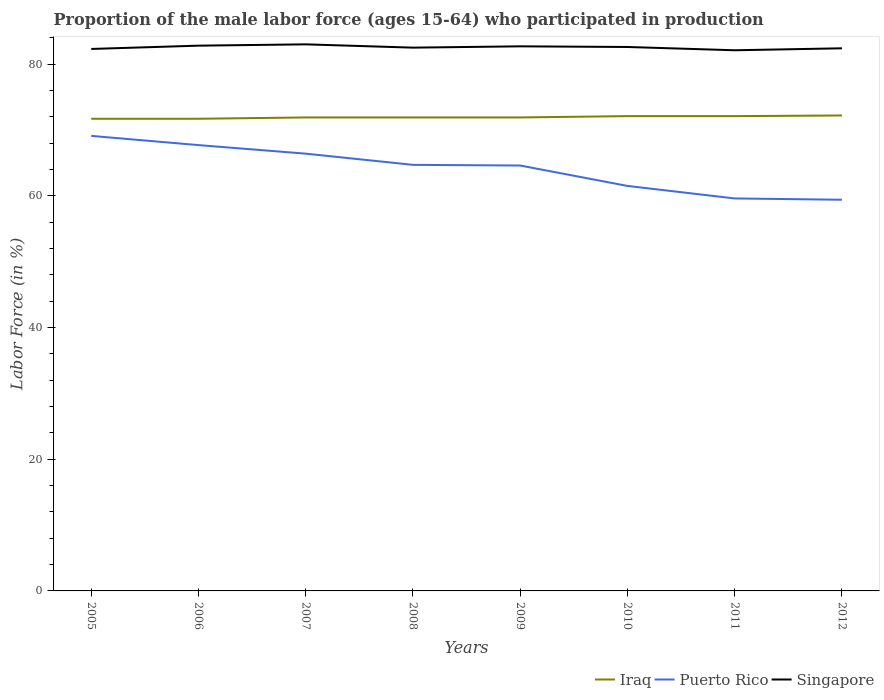How many different coloured lines are there?
Provide a succinct answer. 3. Across all years, what is the maximum proportion of the male labor force who participated in production in Singapore?
Provide a succinct answer. 82.1. What is the total proportion of the male labor force who participated in production in Singapore in the graph?
Provide a succinct answer. 0.4. What is the difference between the highest and the second highest proportion of the male labor force who participated in production in Singapore?
Ensure brevity in your answer.  0.9. Is the proportion of the male labor force who participated in production in Iraq strictly greater than the proportion of the male labor force who participated in production in Singapore over the years?
Offer a terse response. Yes. How many lines are there?
Provide a short and direct response. 3. How many years are there in the graph?
Your answer should be very brief. 8. Does the graph contain any zero values?
Keep it short and to the point. No. Does the graph contain grids?
Give a very brief answer. No. How are the legend labels stacked?
Offer a very short reply. Horizontal. What is the title of the graph?
Your answer should be very brief. Proportion of the male labor force (ages 15-64) who participated in production. Does "Channel Islands" appear as one of the legend labels in the graph?
Offer a terse response. No. What is the label or title of the X-axis?
Your answer should be compact. Years. What is the Labor Force (in %) of Iraq in 2005?
Your answer should be very brief. 71.7. What is the Labor Force (in %) of Puerto Rico in 2005?
Your answer should be very brief. 69.1. What is the Labor Force (in %) of Singapore in 2005?
Your response must be concise. 82.3. What is the Labor Force (in %) in Iraq in 2006?
Your answer should be compact. 71.7. What is the Labor Force (in %) in Puerto Rico in 2006?
Offer a very short reply. 67.7. What is the Labor Force (in %) of Singapore in 2006?
Your answer should be very brief. 82.8. What is the Labor Force (in %) of Iraq in 2007?
Your answer should be very brief. 71.9. What is the Labor Force (in %) in Puerto Rico in 2007?
Your answer should be compact. 66.4. What is the Labor Force (in %) of Iraq in 2008?
Ensure brevity in your answer.  71.9. What is the Labor Force (in %) in Puerto Rico in 2008?
Give a very brief answer. 64.7. What is the Labor Force (in %) of Singapore in 2008?
Your response must be concise. 82.5. What is the Labor Force (in %) in Iraq in 2009?
Your answer should be very brief. 71.9. What is the Labor Force (in %) in Puerto Rico in 2009?
Keep it short and to the point. 64.6. What is the Labor Force (in %) in Singapore in 2009?
Offer a terse response. 82.7. What is the Labor Force (in %) in Iraq in 2010?
Ensure brevity in your answer.  72.1. What is the Labor Force (in %) of Puerto Rico in 2010?
Ensure brevity in your answer.  61.5. What is the Labor Force (in %) of Singapore in 2010?
Your answer should be compact. 82.6. What is the Labor Force (in %) in Iraq in 2011?
Your answer should be very brief. 72.1. What is the Labor Force (in %) of Puerto Rico in 2011?
Ensure brevity in your answer.  59.6. What is the Labor Force (in %) of Singapore in 2011?
Ensure brevity in your answer.  82.1. What is the Labor Force (in %) of Iraq in 2012?
Keep it short and to the point. 72.2. What is the Labor Force (in %) in Puerto Rico in 2012?
Your answer should be compact. 59.4. What is the Labor Force (in %) in Singapore in 2012?
Make the answer very short. 82.4. Across all years, what is the maximum Labor Force (in %) of Iraq?
Keep it short and to the point. 72.2. Across all years, what is the maximum Labor Force (in %) of Puerto Rico?
Your response must be concise. 69.1. Across all years, what is the maximum Labor Force (in %) of Singapore?
Give a very brief answer. 83. Across all years, what is the minimum Labor Force (in %) in Iraq?
Your answer should be very brief. 71.7. Across all years, what is the minimum Labor Force (in %) of Puerto Rico?
Make the answer very short. 59.4. Across all years, what is the minimum Labor Force (in %) of Singapore?
Provide a succinct answer. 82.1. What is the total Labor Force (in %) in Iraq in the graph?
Give a very brief answer. 575.5. What is the total Labor Force (in %) of Puerto Rico in the graph?
Your response must be concise. 513. What is the total Labor Force (in %) of Singapore in the graph?
Your answer should be compact. 660.4. What is the difference between the Labor Force (in %) in Singapore in 2005 and that in 2006?
Offer a very short reply. -0.5. What is the difference between the Labor Force (in %) in Puerto Rico in 2005 and that in 2007?
Your answer should be compact. 2.7. What is the difference between the Labor Force (in %) in Singapore in 2005 and that in 2007?
Make the answer very short. -0.7. What is the difference between the Labor Force (in %) in Iraq in 2005 and that in 2008?
Offer a very short reply. -0.2. What is the difference between the Labor Force (in %) of Puerto Rico in 2005 and that in 2008?
Provide a succinct answer. 4.4. What is the difference between the Labor Force (in %) in Singapore in 2005 and that in 2008?
Your answer should be very brief. -0.2. What is the difference between the Labor Force (in %) of Iraq in 2005 and that in 2009?
Make the answer very short. -0.2. What is the difference between the Labor Force (in %) in Puerto Rico in 2005 and that in 2009?
Your response must be concise. 4.5. What is the difference between the Labor Force (in %) of Iraq in 2005 and that in 2010?
Your answer should be compact. -0.4. What is the difference between the Labor Force (in %) of Puerto Rico in 2005 and that in 2011?
Your answer should be compact. 9.5. What is the difference between the Labor Force (in %) of Singapore in 2005 and that in 2011?
Offer a terse response. 0.2. What is the difference between the Labor Force (in %) of Iraq in 2005 and that in 2012?
Your response must be concise. -0.5. What is the difference between the Labor Force (in %) of Singapore in 2005 and that in 2012?
Ensure brevity in your answer.  -0.1. What is the difference between the Labor Force (in %) of Iraq in 2006 and that in 2007?
Make the answer very short. -0.2. What is the difference between the Labor Force (in %) in Iraq in 2006 and that in 2008?
Your response must be concise. -0.2. What is the difference between the Labor Force (in %) of Puerto Rico in 2006 and that in 2008?
Offer a terse response. 3. What is the difference between the Labor Force (in %) of Singapore in 2006 and that in 2008?
Ensure brevity in your answer.  0.3. What is the difference between the Labor Force (in %) of Iraq in 2006 and that in 2009?
Your answer should be compact. -0.2. What is the difference between the Labor Force (in %) of Puerto Rico in 2006 and that in 2010?
Provide a succinct answer. 6.2. What is the difference between the Labor Force (in %) in Iraq in 2006 and that in 2011?
Keep it short and to the point. -0.4. What is the difference between the Labor Force (in %) in Puerto Rico in 2006 and that in 2011?
Provide a short and direct response. 8.1. What is the difference between the Labor Force (in %) of Singapore in 2006 and that in 2011?
Offer a terse response. 0.7. What is the difference between the Labor Force (in %) of Iraq in 2007 and that in 2008?
Your answer should be very brief. 0. What is the difference between the Labor Force (in %) in Puerto Rico in 2007 and that in 2008?
Offer a very short reply. 1.7. What is the difference between the Labor Force (in %) of Singapore in 2007 and that in 2008?
Your response must be concise. 0.5. What is the difference between the Labor Force (in %) in Iraq in 2007 and that in 2009?
Provide a succinct answer. 0. What is the difference between the Labor Force (in %) of Iraq in 2007 and that in 2011?
Your response must be concise. -0.2. What is the difference between the Labor Force (in %) in Puerto Rico in 2007 and that in 2011?
Provide a succinct answer. 6.8. What is the difference between the Labor Force (in %) in Singapore in 2007 and that in 2011?
Offer a very short reply. 0.9. What is the difference between the Labor Force (in %) of Iraq in 2007 and that in 2012?
Keep it short and to the point. -0.3. What is the difference between the Labor Force (in %) of Singapore in 2007 and that in 2012?
Provide a short and direct response. 0.6. What is the difference between the Labor Force (in %) in Iraq in 2008 and that in 2010?
Make the answer very short. -0.2. What is the difference between the Labor Force (in %) in Puerto Rico in 2008 and that in 2010?
Your response must be concise. 3.2. What is the difference between the Labor Force (in %) of Iraq in 2008 and that in 2011?
Offer a very short reply. -0.2. What is the difference between the Labor Force (in %) in Puerto Rico in 2008 and that in 2012?
Provide a short and direct response. 5.3. What is the difference between the Labor Force (in %) in Singapore in 2008 and that in 2012?
Your answer should be compact. 0.1. What is the difference between the Labor Force (in %) of Iraq in 2009 and that in 2010?
Give a very brief answer. -0.2. What is the difference between the Labor Force (in %) in Puerto Rico in 2009 and that in 2011?
Provide a short and direct response. 5. What is the difference between the Labor Force (in %) in Singapore in 2009 and that in 2011?
Offer a very short reply. 0.6. What is the difference between the Labor Force (in %) of Puerto Rico in 2009 and that in 2012?
Provide a short and direct response. 5.2. What is the difference between the Labor Force (in %) of Iraq in 2010 and that in 2011?
Your answer should be very brief. 0. What is the difference between the Labor Force (in %) in Singapore in 2010 and that in 2011?
Your response must be concise. 0.5. What is the difference between the Labor Force (in %) of Iraq in 2010 and that in 2012?
Give a very brief answer. -0.1. What is the difference between the Labor Force (in %) in Puerto Rico in 2010 and that in 2012?
Give a very brief answer. 2.1. What is the difference between the Labor Force (in %) of Singapore in 2010 and that in 2012?
Keep it short and to the point. 0.2. What is the difference between the Labor Force (in %) of Puerto Rico in 2011 and that in 2012?
Provide a short and direct response. 0.2. What is the difference between the Labor Force (in %) in Singapore in 2011 and that in 2012?
Offer a terse response. -0.3. What is the difference between the Labor Force (in %) in Iraq in 2005 and the Labor Force (in %) in Puerto Rico in 2006?
Offer a terse response. 4. What is the difference between the Labor Force (in %) in Iraq in 2005 and the Labor Force (in %) in Singapore in 2006?
Give a very brief answer. -11.1. What is the difference between the Labor Force (in %) of Puerto Rico in 2005 and the Labor Force (in %) of Singapore in 2006?
Offer a very short reply. -13.7. What is the difference between the Labor Force (in %) of Puerto Rico in 2005 and the Labor Force (in %) of Singapore in 2007?
Keep it short and to the point. -13.9. What is the difference between the Labor Force (in %) of Iraq in 2005 and the Labor Force (in %) of Singapore in 2008?
Make the answer very short. -10.8. What is the difference between the Labor Force (in %) of Iraq in 2005 and the Labor Force (in %) of Singapore in 2009?
Ensure brevity in your answer.  -11. What is the difference between the Labor Force (in %) in Puerto Rico in 2005 and the Labor Force (in %) in Singapore in 2010?
Offer a very short reply. -13.5. What is the difference between the Labor Force (in %) of Puerto Rico in 2005 and the Labor Force (in %) of Singapore in 2011?
Make the answer very short. -13. What is the difference between the Labor Force (in %) of Iraq in 2005 and the Labor Force (in %) of Puerto Rico in 2012?
Give a very brief answer. 12.3. What is the difference between the Labor Force (in %) in Iraq in 2005 and the Labor Force (in %) in Singapore in 2012?
Offer a terse response. -10.7. What is the difference between the Labor Force (in %) in Puerto Rico in 2005 and the Labor Force (in %) in Singapore in 2012?
Give a very brief answer. -13.3. What is the difference between the Labor Force (in %) of Iraq in 2006 and the Labor Force (in %) of Puerto Rico in 2007?
Give a very brief answer. 5.3. What is the difference between the Labor Force (in %) of Puerto Rico in 2006 and the Labor Force (in %) of Singapore in 2007?
Offer a very short reply. -15.3. What is the difference between the Labor Force (in %) of Iraq in 2006 and the Labor Force (in %) of Puerto Rico in 2008?
Ensure brevity in your answer.  7. What is the difference between the Labor Force (in %) of Iraq in 2006 and the Labor Force (in %) of Singapore in 2008?
Your answer should be very brief. -10.8. What is the difference between the Labor Force (in %) of Puerto Rico in 2006 and the Labor Force (in %) of Singapore in 2008?
Offer a terse response. -14.8. What is the difference between the Labor Force (in %) of Iraq in 2006 and the Labor Force (in %) of Puerto Rico in 2010?
Ensure brevity in your answer.  10.2. What is the difference between the Labor Force (in %) of Puerto Rico in 2006 and the Labor Force (in %) of Singapore in 2010?
Provide a short and direct response. -14.9. What is the difference between the Labor Force (in %) in Iraq in 2006 and the Labor Force (in %) in Singapore in 2011?
Keep it short and to the point. -10.4. What is the difference between the Labor Force (in %) in Puerto Rico in 2006 and the Labor Force (in %) in Singapore in 2011?
Give a very brief answer. -14.4. What is the difference between the Labor Force (in %) in Iraq in 2006 and the Labor Force (in %) in Singapore in 2012?
Your response must be concise. -10.7. What is the difference between the Labor Force (in %) of Puerto Rico in 2006 and the Labor Force (in %) of Singapore in 2012?
Ensure brevity in your answer.  -14.7. What is the difference between the Labor Force (in %) of Puerto Rico in 2007 and the Labor Force (in %) of Singapore in 2008?
Your answer should be very brief. -16.1. What is the difference between the Labor Force (in %) in Iraq in 2007 and the Labor Force (in %) in Singapore in 2009?
Ensure brevity in your answer.  -10.8. What is the difference between the Labor Force (in %) of Puerto Rico in 2007 and the Labor Force (in %) of Singapore in 2009?
Provide a short and direct response. -16.3. What is the difference between the Labor Force (in %) of Puerto Rico in 2007 and the Labor Force (in %) of Singapore in 2010?
Your answer should be very brief. -16.2. What is the difference between the Labor Force (in %) in Puerto Rico in 2007 and the Labor Force (in %) in Singapore in 2011?
Offer a very short reply. -15.7. What is the difference between the Labor Force (in %) in Puerto Rico in 2007 and the Labor Force (in %) in Singapore in 2012?
Give a very brief answer. -16. What is the difference between the Labor Force (in %) in Iraq in 2008 and the Labor Force (in %) in Puerto Rico in 2009?
Give a very brief answer. 7.3. What is the difference between the Labor Force (in %) of Iraq in 2008 and the Labor Force (in %) of Singapore in 2009?
Keep it short and to the point. -10.8. What is the difference between the Labor Force (in %) in Puerto Rico in 2008 and the Labor Force (in %) in Singapore in 2009?
Offer a terse response. -18. What is the difference between the Labor Force (in %) in Iraq in 2008 and the Labor Force (in %) in Singapore in 2010?
Offer a terse response. -10.7. What is the difference between the Labor Force (in %) of Puerto Rico in 2008 and the Labor Force (in %) of Singapore in 2010?
Give a very brief answer. -17.9. What is the difference between the Labor Force (in %) of Iraq in 2008 and the Labor Force (in %) of Puerto Rico in 2011?
Make the answer very short. 12.3. What is the difference between the Labor Force (in %) of Puerto Rico in 2008 and the Labor Force (in %) of Singapore in 2011?
Offer a terse response. -17.4. What is the difference between the Labor Force (in %) in Iraq in 2008 and the Labor Force (in %) in Puerto Rico in 2012?
Your response must be concise. 12.5. What is the difference between the Labor Force (in %) in Iraq in 2008 and the Labor Force (in %) in Singapore in 2012?
Keep it short and to the point. -10.5. What is the difference between the Labor Force (in %) in Puerto Rico in 2008 and the Labor Force (in %) in Singapore in 2012?
Keep it short and to the point. -17.7. What is the difference between the Labor Force (in %) in Iraq in 2009 and the Labor Force (in %) in Singapore in 2010?
Your answer should be compact. -10.7. What is the difference between the Labor Force (in %) of Puerto Rico in 2009 and the Labor Force (in %) of Singapore in 2010?
Ensure brevity in your answer.  -18. What is the difference between the Labor Force (in %) in Iraq in 2009 and the Labor Force (in %) in Singapore in 2011?
Keep it short and to the point. -10.2. What is the difference between the Labor Force (in %) in Puerto Rico in 2009 and the Labor Force (in %) in Singapore in 2011?
Make the answer very short. -17.5. What is the difference between the Labor Force (in %) in Iraq in 2009 and the Labor Force (in %) in Puerto Rico in 2012?
Your answer should be very brief. 12.5. What is the difference between the Labor Force (in %) in Iraq in 2009 and the Labor Force (in %) in Singapore in 2012?
Give a very brief answer. -10.5. What is the difference between the Labor Force (in %) of Puerto Rico in 2009 and the Labor Force (in %) of Singapore in 2012?
Provide a short and direct response. -17.8. What is the difference between the Labor Force (in %) of Iraq in 2010 and the Labor Force (in %) of Puerto Rico in 2011?
Offer a terse response. 12.5. What is the difference between the Labor Force (in %) in Iraq in 2010 and the Labor Force (in %) in Singapore in 2011?
Offer a very short reply. -10. What is the difference between the Labor Force (in %) in Puerto Rico in 2010 and the Labor Force (in %) in Singapore in 2011?
Your response must be concise. -20.6. What is the difference between the Labor Force (in %) in Iraq in 2010 and the Labor Force (in %) in Singapore in 2012?
Provide a succinct answer. -10.3. What is the difference between the Labor Force (in %) of Puerto Rico in 2010 and the Labor Force (in %) of Singapore in 2012?
Your answer should be very brief. -20.9. What is the difference between the Labor Force (in %) in Puerto Rico in 2011 and the Labor Force (in %) in Singapore in 2012?
Offer a terse response. -22.8. What is the average Labor Force (in %) in Iraq per year?
Ensure brevity in your answer.  71.94. What is the average Labor Force (in %) of Puerto Rico per year?
Offer a terse response. 64.12. What is the average Labor Force (in %) in Singapore per year?
Give a very brief answer. 82.55. In the year 2005, what is the difference between the Labor Force (in %) in Iraq and Labor Force (in %) in Singapore?
Your response must be concise. -10.6. In the year 2005, what is the difference between the Labor Force (in %) in Puerto Rico and Labor Force (in %) in Singapore?
Your answer should be very brief. -13.2. In the year 2006, what is the difference between the Labor Force (in %) of Iraq and Labor Force (in %) of Puerto Rico?
Ensure brevity in your answer.  4. In the year 2006, what is the difference between the Labor Force (in %) of Puerto Rico and Labor Force (in %) of Singapore?
Make the answer very short. -15.1. In the year 2007, what is the difference between the Labor Force (in %) of Puerto Rico and Labor Force (in %) of Singapore?
Your answer should be compact. -16.6. In the year 2008, what is the difference between the Labor Force (in %) of Puerto Rico and Labor Force (in %) of Singapore?
Provide a short and direct response. -17.8. In the year 2009, what is the difference between the Labor Force (in %) of Iraq and Labor Force (in %) of Singapore?
Your answer should be compact. -10.8. In the year 2009, what is the difference between the Labor Force (in %) in Puerto Rico and Labor Force (in %) in Singapore?
Offer a terse response. -18.1. In the year 2010, what is the difference between the Labor Force (in %) in Iraq and Labor Force (in %) in Puerto Rico?
Your answer should be compact. 10.6. In the year 2010, what is the difference between the Labor Force (in %) in Puerto Rico and Labor Force (in %) in Singapore?
Your answer should be very brief. -21.1. In the year 2011, what is the difference between the Labor Force (in %) in Iraq and Labor Force (in %) in Puerto Rico?
Keep it short and to the point. 12.5. In the year 2011, what is the difference between the Labor Force (in %) in Iraq and Labor Force (in %) in Singapore?
Your answer should be very brief. -10. In the year 2011, what is the difference between the Labor Force (in %) of Puerto Rico and Labor Force (in %) of Singapore?
Keep it short and to the point. -22.5. In the year 2012, what is the difference between the Labor Force (in %) in Puerto Rico and Labor Force (in %) in Singapore?
Your answer should be very brief. -23. What is the ratio of the Labor Force (in %) of Puerto Rico in 2005 to that in 2006?
Your answer should be very brief. 1.02. What is the ratio of the Labor Force (in %) of Iraq in 2005 to that in 2007?
Provide a succinct answer. 1. What is the ratio of the Labor Force (in %) of Puerto Rico in 2005 to that in 2007?
Make the answer very short. 1.04. What is the ratio of the Labor Force (in %) of Singapore in 2005 to that in 2007?
Give a very brief answer. 0.99. What is the ratio of the Labor Force (in %) in Iraq in 2005 to that in 2008?
Provide a succinct answer. 1. What is the ratio of the Labor Force (in %) of Puerto Rico in 2005 to that in 2008?
Your answer should be compact. 1.07. What is the ratio of the Labor Force (in %) of Puerto Rico in 2005 to that in 2009?
Offer a very short reply. 1.07. What is the ratio of the Labor Force (in %) of Puerto Rico in 2005 to that in 2010?
Ensure brevity in your answer.  1.12. What is the ratio of the Labor Force (in %) in Singapore in 2005 to that in 2010?
Keep it short and to the point. 1. What is the ratio of the Labor Force (in %) of Puerto Rico in 2005 to that in 2011?
Make the answer very short. 1.16. What is the ratio of the Labor Force (in %) of Puerto Rico in 2005 to that in 2012?
Your answer should be very brief. 1.16. What is the ratio of the Labor Force (in %) of Iraq in 2006 to that in 2007?
Your answer should be very brief. 1. What is the ratio of the Labor Force (in %) of Puerto Rico in 2006 to that in 2007?
Provide a short and direct response. 1.02. What is the ratio of the Labor Force (in %) of Singapore in 2006 to that in 2007?
Provide a short and direct response. 1. What is the ratio of the Labor Force (in %) in Puerto Rico in 2006 to that in 2008?
Ensure brevity in your answer.  1.05. What is the ratio of the Labor Force (in %) of Singapore in 2006 to that in 2008?
Your response must be concise. 1. What is the ratio of the Labor Force (in %) of Iraq in 2006 to that in 2009?
Your answer should be compact. 1. What is the ratio of the Labor Force (in %) in Puerto Rico in 2006 to that in 2009?
Offer a very short reply. 1.05. What is the ratio of the Labor Force (in %) in Iraq in 2006 to that in 2010?
Your answer should be very brief. 0.99. What is the ratio of the Labor Force (in %) in Puerto Rico in 2006 to that in 2010?
Offer a very short reply. 1.1. What is the ratio of the Labor Force (in %) in Singapore in 2006 to that in 2010?
Make the answer very short. 1. What is the ratio of the Labor Force (in %) of Puerto Rico in 2006 to that in 2011?
Offer a very short reply. 1.14. What is the ratio of the Labor Force (in %) of Singapore in 2006 to that in 2011?
Your answer should be compact. 1.01. What is the ratio of the Labor Force (in %) in Iraq in 2006 to that in 2012?
Your response must be concise. 0.99. What is the ratio of the Labor Force (in %) of Puerto Rico in 2006 to that in 2012?
Give a very brief answer. 1.14. What is the ratio of the Labor Force (in %) of Singapore in 2006 to that in 2012?
Your response must be concise. 1. What is the ratio of the Labor Force (in %) in Iraq in 2007 to that in 2008?
Ensure brevity in your answer.  1. What is the ratio of the Labor Force (in %) in Puerto Rico in 2007 to that in 2008?
Your response must be concise. 1.03. What is the ratio of the Labor Force (in %) in Puerto Rico in 2007 to that in 2009?
Provide a succinct answer. 1.03. What is the ratio of the Labor Force (in %) of Singapore in 2007 to that in 2009?
Offer a terse response. 1. What is the ratio of the Labor Force (in %) of Puerto Rico in 2007 to that in 2010?
Make the answer very short. 1.08. What is the ratio of the Labor Force (in %) of Singapore in 2007 to that in 2010?
Make the answer very short. 1. What is the ratio of the Labor Force (in %) in Iraq in 2007 to that in 2011?
Your answer should be very brief. 1. What is the ratio of the Labor Force (in %) in Puerto Rico in 2007 to that in 2011?
Your response must be concise. 1.11. What is the ratio of the Labor Force (in %) of Singapore in 2007 to that in 2011?
Ensure brevity in your answer.  1.01. What is the ratio of the Labor Force (in %) in Puerto Rico in 2007 to that in 2012?
Provide a succinct answer. 1.12. What is the ratio of the Labor Force (in %) of Singapore in 2007 to that in 2012?
Keep it short and to the point. 1.01. What is the ratio of the Labor Force (in %) of Puerto Rico in 2008 to that in 2009?
Give a very brief answer. 1. What is the ratio of the Labor Force (in %) in Iraq in 2008 to that in 2010?
Offer a very short reply. 1. What is the ratio of the Labor Force (in %) in Puerto Rico in 2008 to that in 2010?
Keep it short and to the point. 1.05. What is the ratio of the Labor Force (in %) in Singapore in 2008 to that in 2010?
Keep it short and to the point. 1. What is the ratio of the Labor Force (in %) of Puerto Rico in 2008 to that in 2011?
Your answer should be compact. 1.09. What is the ratio of the Labor Force (in %) of Singapore in 2008 to that in 2011?
Give a very brief answer. 1. What is the ratio of the Labor Force (in %) of Iraq in 2008 to that in 2012?
Ensure brevity in your answer.  1. What is the ratio of the Labor Force (in %) in Puerto Rico in 2008 to that in 2012?
Provide a short and direct response. 1.09. What is the ratio of the Labor Force (in %) in Singapore in 2008 to that in 2012?
Ensure brevity in your answer.  1. What is the ratio of the Labor Force (in %) of Puerto Rico in 2009 to that in 2010?
Offer a very short reply. 1.05. What is the ratio of the Labor Force (in %) of Singapore in 2009 to that in 2010?
Offer a terse response. 1. What is the ratio of the Labor Force (in %) in Puerto Rico in 2009 to that in 2011?
Provide a short and direct response. 1.08. What is the ratio of the Labor Force (in %) of Singapore in 2009 to that in 2011?
Your answer should be very brief. 1.01. What is the ratio of the Labor Force (in %) in Iraq in 2009 to that in 2012?
Your response must be concise. 1. What is the ratio of the Labor Force (in %) in Puerto Rico in 2009 to that in 2012?
Offer a terse response. 1.09. What is the ratio of the Labor Force (in %) of Puerto Rico in 2010 to that in 2011?
Your response must be concise. 1.03. What is the ratio of the Labor Force (in %) in Iraq in 2010 to that in 2012?
Your answer should be compact. 1. What is the ratio of the Labor Force (in %) of Puerto Rico in 2010 to that in 2012?
Keep it short and to the point. 1.04. What is the ratio of the Labor Force (in %) in Singapore in 2010 to that in 2012?
Offer a terse response. 1. What is the ratio of the Labor Force (in %) in Iraq in 2011 to that in 2012?
Give a very brief answer. 1. What is the ratio of the Labor Force (in %) in Puerto Rico in 2011 to that in 2012?
Give a very brief answer. 1. What is the difference between the highest and the second highest Labor Force (in %) in Iraq?
Your response must be concise. 0.1. What is the difference between the highest and the second highest Labor Force (in %) in Puerto Rico?
Keep it short and to the point. 1.4. What is the difference between the highest and the second highest Labor Force (in %) in Singapore?
Your answer should be compact. 0.2. 